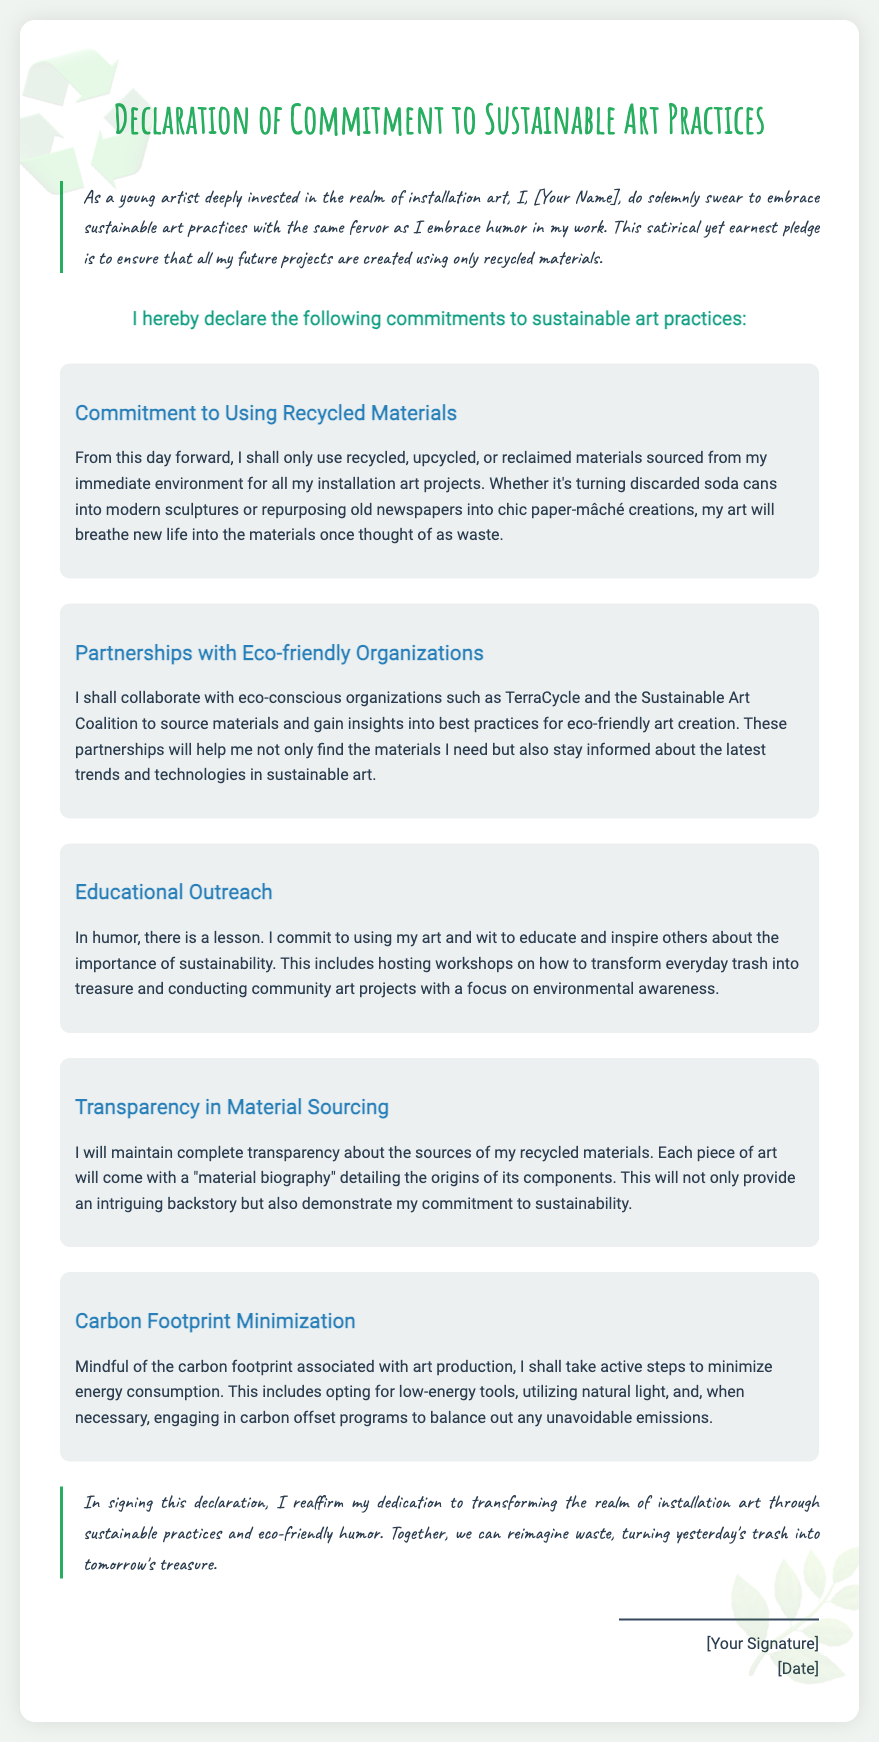What materials will the artist commit to using? The artist commits to using recycled, upcycled, or reclaimed materials sourced from the immediate environment.
Answer: recycled, upcycled, or reclaimed materials Which organizations will the artist partner with? The artist mentions partnering with eco-conscious organizations such as TerraCycle and the Sustainable Art Coalition.
Answer: TerraCycle and the Sustainable Art Coalition What is included with each piece of art? Each piece of art will come with a "material biography" detailing the origins of its components.
Answer: "material biography" What is the artist's commitment regarding educational outreach? The artist commits to using art and wit to educate and inspire others about the importance of sustainability.
Answer: educate and inspire others What is the artist's approach towards carbon footprint? The artist shall take active steps to minimize energy consumption.
Answer: minimize energy consumption How does the document describe the tone of the pledge? The pledge is described as satirical yet earnest.
Answer: satirical yet earnest What will artists transform in their projects? Artists will transform everyday trash into treasure.
Answer: everyday trash into treasure What is the date section for? The date section is for the date when the declaration is signed.
Answer: date when the declaration is signed 